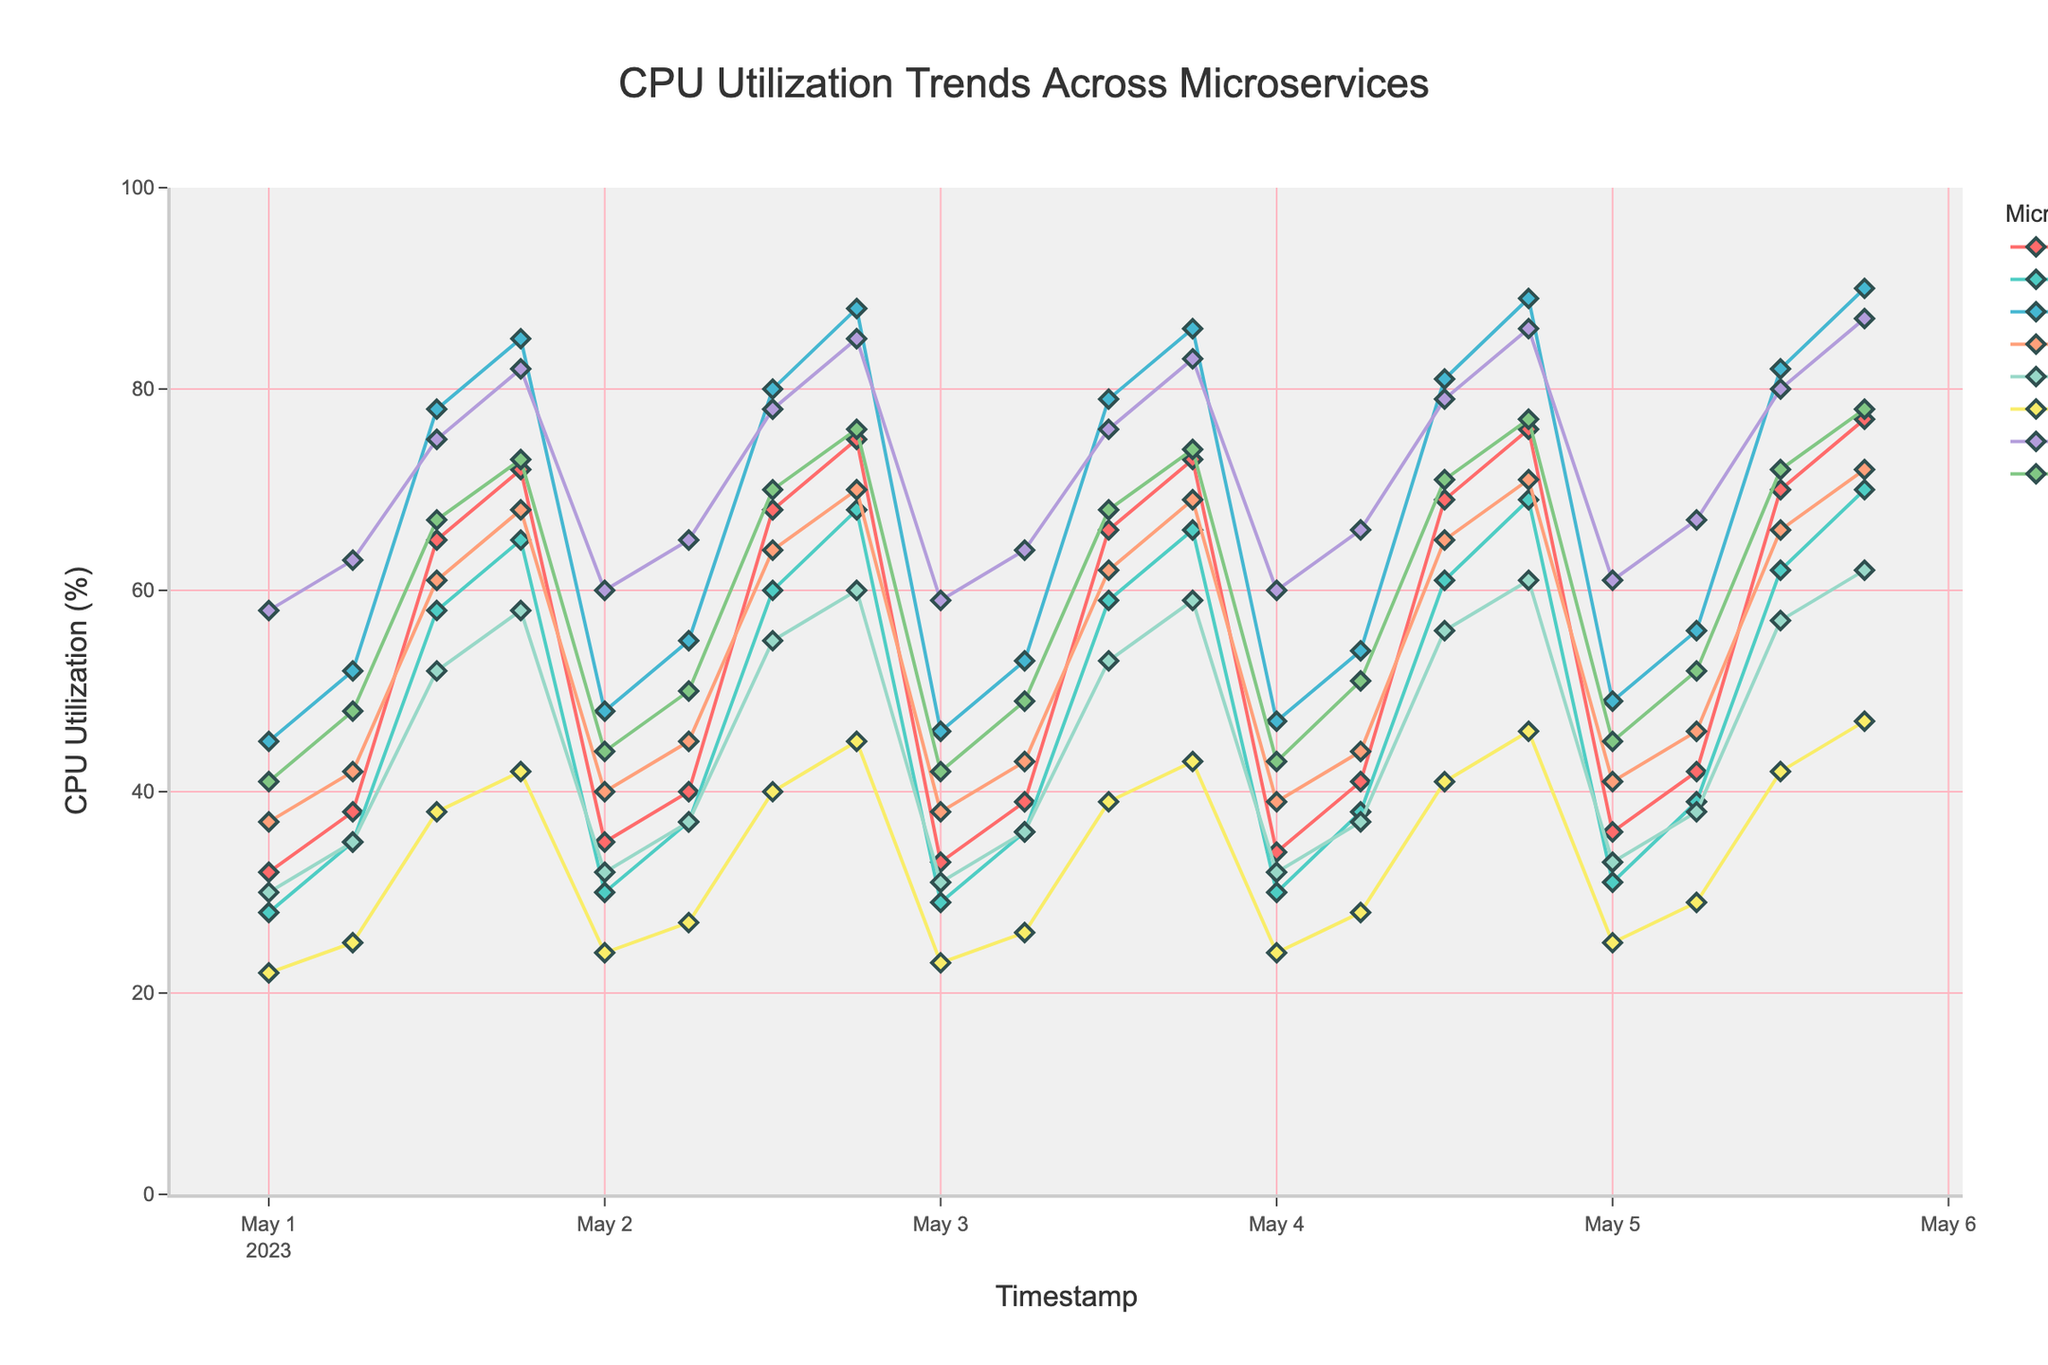What is the highest CPU utilization recorded for the Payment Service, and when did it occur? First, identify the line corresponding to the Payment Service, which is represented by a specific color on the chart. Look for the peak of this line and note the corresponding timestamp on the x-axis. The highest point in the Payment Service line is at the timestamp "2023-05-05 18:00:00."
Answer: 62% on 2023-05-05 18:00:00 Which microservice has the overall highest CPU utilization, and what is its maximum value? Identify the highest points of all the lines representing each microservice. The Recommendation Engine reaches the highest overall CPU utilization at 90%.
Answer: Recommendation Engine at 90% On 2023-05-03 at 12:00:00, which microservice was utilizing more CPU, Order Processing or Data Analytics? Look at the data points marked by symbols on the lines for these microservices at the timestamp "2023-05-03 12:00:00." The value for Order Processing is 79%, and for Data Analytics, it is 76%.
Answer: Order Processing What is the average CPU utilization for the API Gateway over the entire period? Sum the CPU utilization values for the API Gateway at all timestamps and divide by the number of timestamps (20). (32 + 38 + 65 + 72 + 35 + 40 + 68 + 75 + 33 + 39 + 66 + 73 + 34 + 41 + 69 + 76 + 36 + 42 + 70 + 77)/20 = 52.8
Answer: 52.8% By comparing peak times, did the Notification Service have increased CPU utilization more frequently in the mornings (6:00 AM) or evenings (6:00 PM)? Compare the peaks for the Notification Service at 6:00 AM and 6:00 PM. The data points for 6:00 AM are relatively lower compared to those at 6:00 PM.
Answer: Evenings (6:00 PM) During peak CPU utilization times, which microservice consistently reaches close to its maximum? Identify the microservices' maximum values and observe which one consistently approaches this value at their respective peaks. The Recommendation Engine reaches close to its maximum value multiple times.
Answer: Recommendation Engine What was the total CPU utilization across all microservices on 2023-05-03 at 18:00:00? Look at the chart and sum the CPU utilization values for all microservices at this timestamp. (73 + 66 + 86 + 69 + 59 + 43 + 83 + 74) = 553%
Answer: 553% 